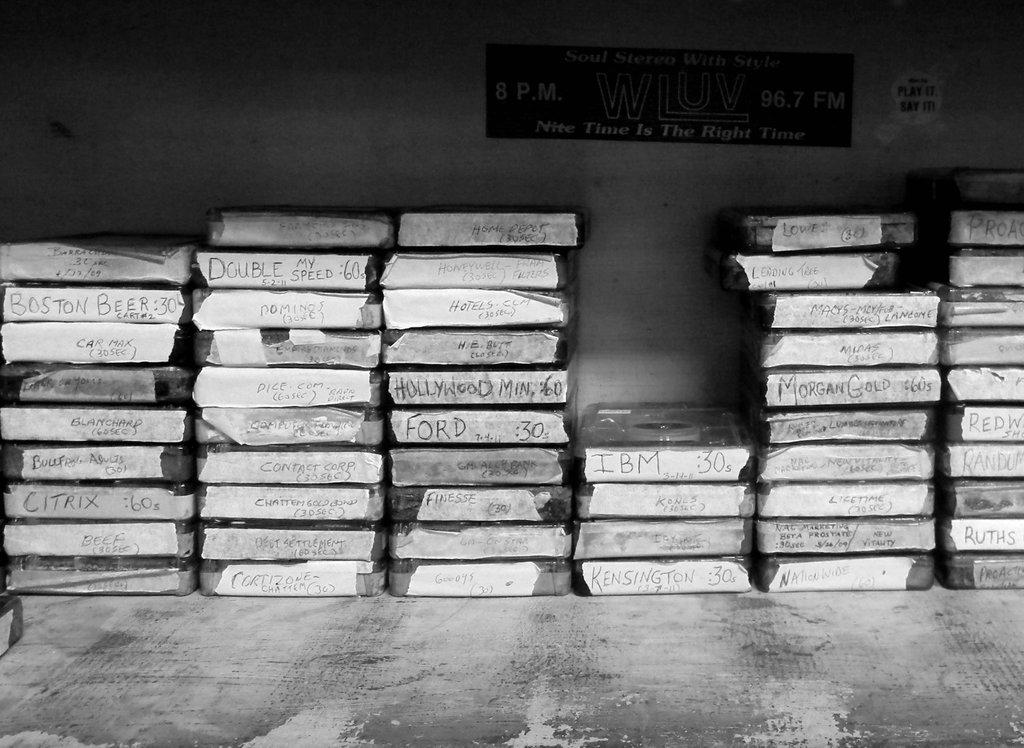Provide a one-sentence caption for the provided image. Stacks of cassette cases with hand written titles on the edges stacked on a gray table by a wall. 